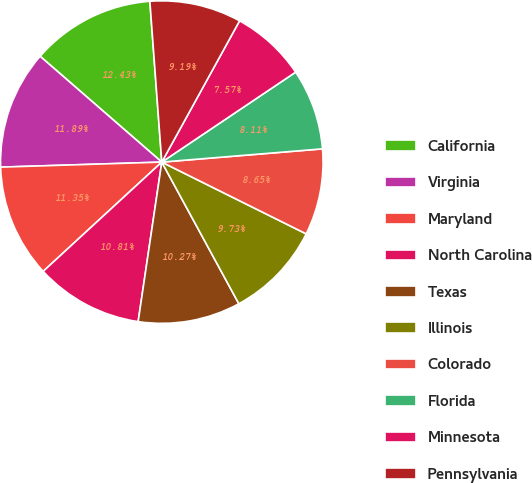Convert chart. <chart><loc_0><loc_0><loc_500><loc_500><pie_chart><fcel>California<fcel>Virginia<fcel>Maryland<fcel>North Carolina<fcel>Texas<fcel>Illinois<fcel>Colorado<fcel>Florida<fcel>Minnesota<fcel>Pennsylvania<nl><fcel>12.43%<fcel>11.89%<fcel>11.35%<fcel>10.81%<fcel>10.27%<fcel>9.73%<fcel>8.65%<fcel>8.11%<fcel>7.57%<fcel>9.19%<nl></chart> 